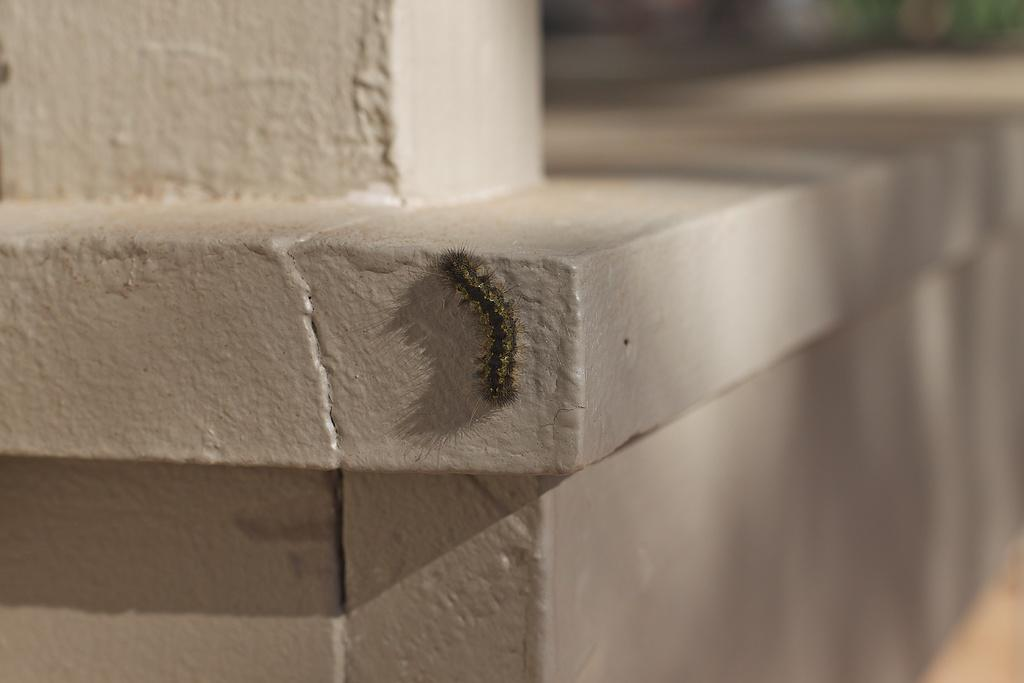What is the main subject of the image? The main subject of the image is a caterpillar. Where is the caterpillar located in the image? The caterpillar is on the wall. What type of cap is the bear wearing in the image? There is no bear or cap present in the image; it only features a caterpillar on the wall. 